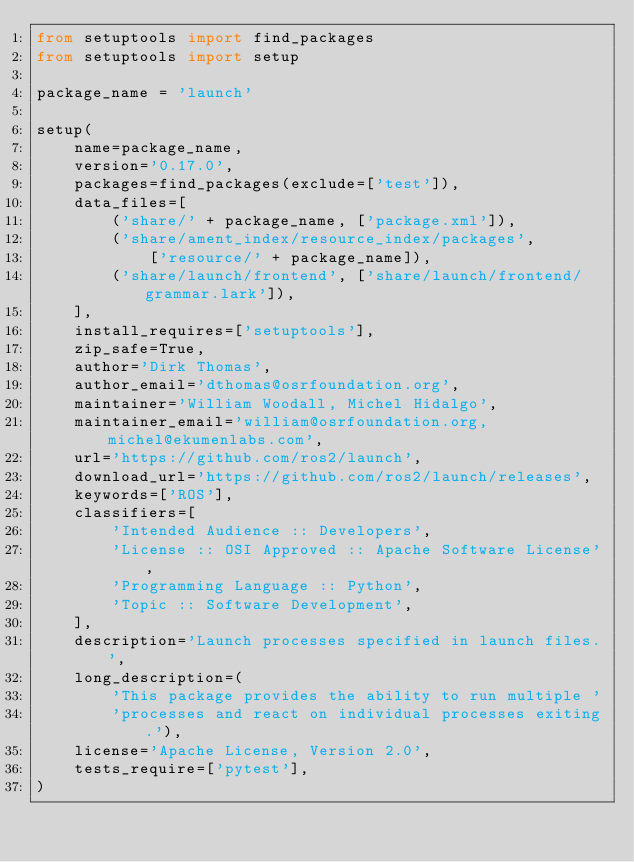<code> <loc_0><loc_0><loc_500><loc_500><_Python_>from setuptools import find_packages
from setuptools import setup

package_name = 'launch'

setup(
    name=package_name,
    version='0.17.0',
    packages=find_packages(exclude=['test']),
    data_files=[
        ('share/' + package_name, ['package.xml']),
        ('share/ament_index/resource_index/packages',
            ['resource/' + package_name]),
        ('share/launch/frontend', ['share/launch/frontend/grammar.lark']),
    ],
    install_requires=['setuptools'],
    zip_safe=True,
    author='Dirk Thomas',
    author_email='dthomas@osrfoundation.org',
    maintainer='William Woodall, Michel Hidalgo',
    maintainer_email='william@osrfoundation.org, michel@ekumenlabs.com',
    url='https://github.com/ros2/launch',
    download_url='https://github.com/ros2/launch/releases',
    keywords=['ROS'],
    classifiers=[
        'Intended Audience :: Developers',
        'License :: OSI Approved :: Apache Software License',
        'Programming Language :: Python',
        'Topic :: Software Development',
    ],
    description='Launch processes specified in launch files.',
    long_description=(
        'This package provides the ability to run multiple '
        'processes and react on individual processes exiting.'),
    license='Apache License, Version 2.0',
    tests_require=['pytest'],
)
</code> 